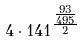Convert formula to latex. <formula><loc_0><loc_0><loc_500><loc_500>4 \cdot 1 4 1 ^ { \frac { \frac { 9 3 } { 4 9 5 } } { 2 } }</formula> 